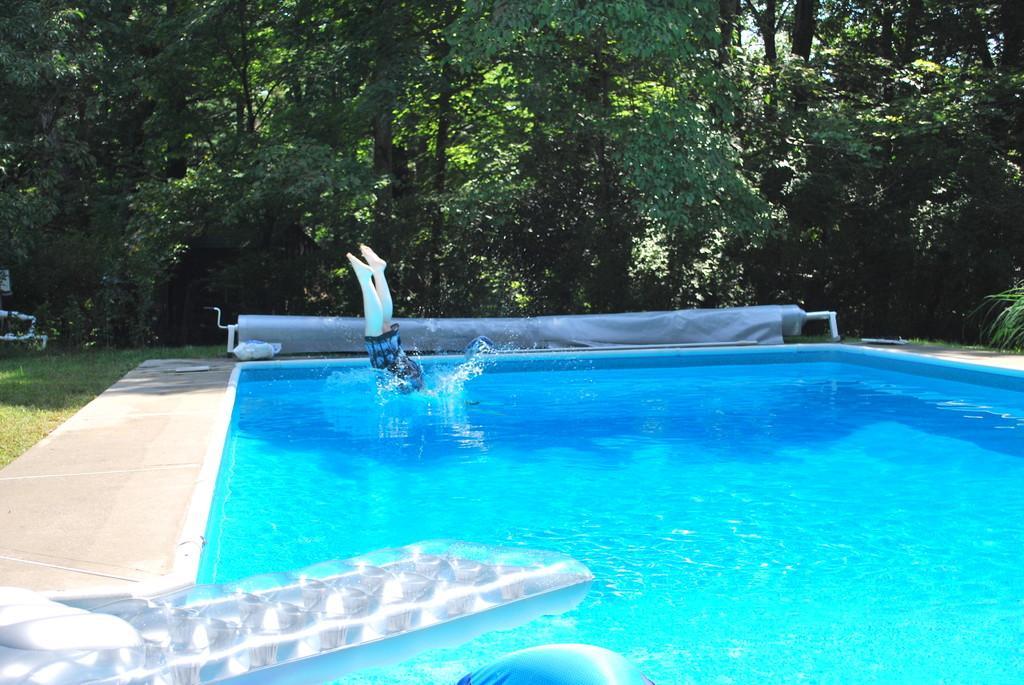In one or two sentences, can you explain what this image depicts? In the picture we can see a swimming pool with water in it and a person jumping into it and around the pool we can see a path and grass surface and in the background we can see trees. 